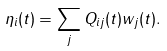<formula> <loc_0><loc_0><loc_500><loc_500>\eta _ { i } ( t ) = \sum _ { j } Q _ { i j } ( t ) w _ { j } ( t ) .</formula> 